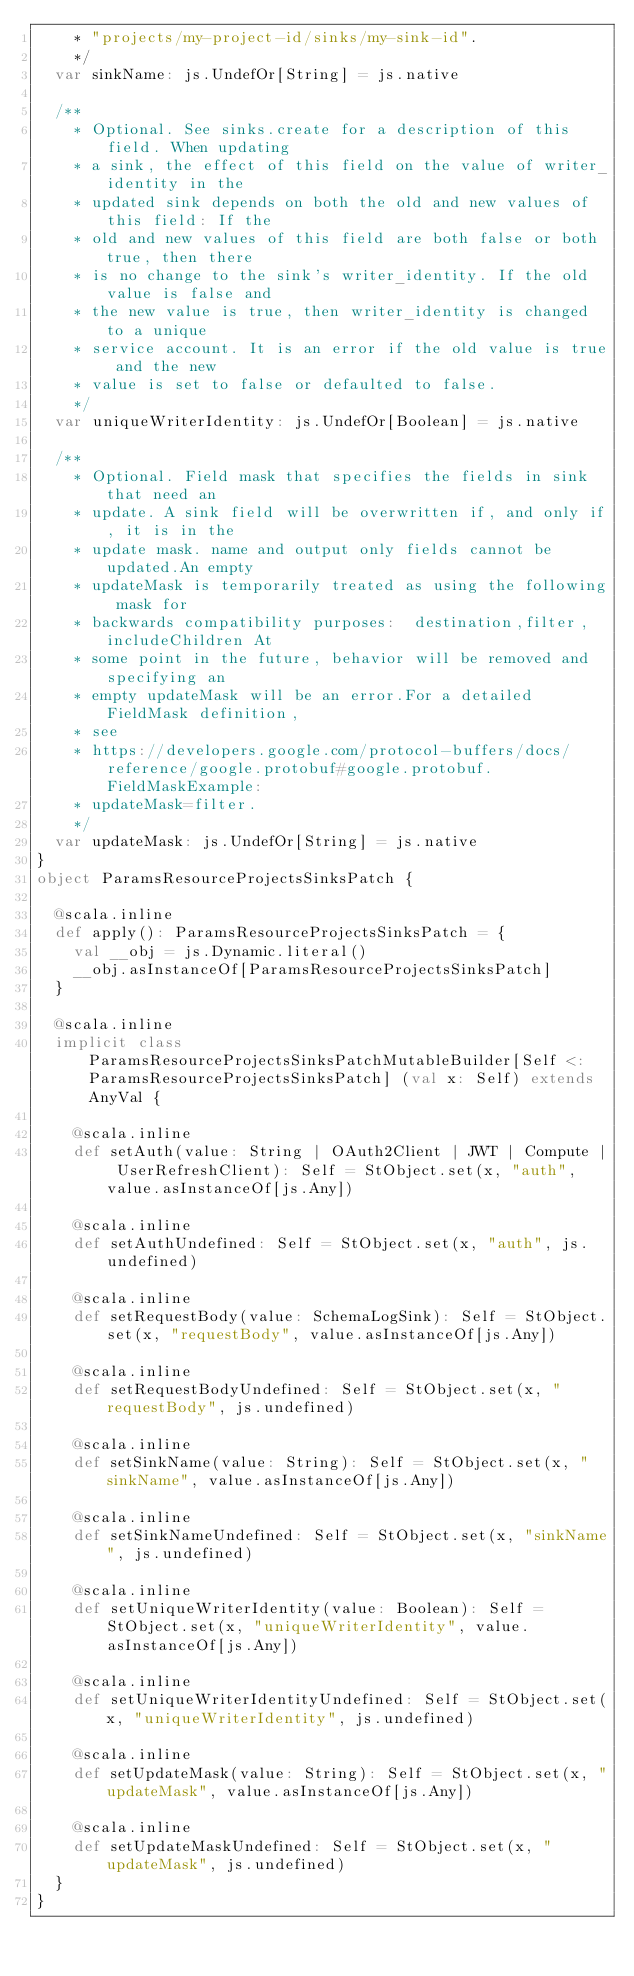<code> <loc_0><loc_0><loc_500><loc_500><_Scala_>    * "projects/my-project-id/sinks/my-sink-id".
    */
  var sinkName: js.UndefOr[String] = js.native
  
  /**
    * Optional. See sinks.create for a description of this field. When updating
    * a sink, the effect of this field on the value of writer_identity in the
    * updated sink depends on both the old and new values of this field: If the
    * old and new values of this field are both false or both true, then there
    * is no change to the sink's writer_identity. If the old value is false and
    * the new value is true, then writer_identity is changed to a unique
    * service account. It is an error if the old value is true and the new
    * value is set to false or defaulted to false.
    */
  var uniqueWriterIdentity: js.UndefOr[Boolean] = js.native
  
  /**
    * Optional. Field mask that specifies the fields in sink that need an
    * update. A sink field will be overwritten if, and only if, it is in the
    * update mask. name and output only fields cannot be updated.An empty
    * updateMask is temporarily treated as using the following mask for
    * backwards compatibility purposes:  destination,filter,includeChildren At
    * some point in the future, behavior will be removed and specifying an
    * empty updateMask will be an error.For a detailed FieldMask definition,
    * see
    * https://developers.google.com/protocol-buffers/docs/reference/google.protobuf#google.protobuf.FieldMaskExample:
    * updateMask=filter.
    */
  var updateMask: js.UndefOr[String] = js.native
}
object ParamsResourceProjectsSinksPatch {
  
  @scala.inline
  def apply(): ParamsResourceProjectsSinksPatch = {
    val __obj = js.Dynamic.literal()
    __obj.asInstanceOf[ParamsResourceProjectsSinksPatch]
  }
  
  @scala.inline
  implicit class ParamsResourceProjectsSinksPatchMutableBuilder[Self <: ParamsResourceProjectsSinksPatch] (val x: Self) extends AnyVal {
    
    @scala.inline
    def setAuth(value: String | OAuth2Client | JWT | Compute | UserRefreshClient): Self = StObject.set(x, "auth", value.asInstanceOf[js.Any])
    
    @scala.inline
    def setAuthUndefined: Self = StObject.set(x, "auth", js.undefined)
    
    @scala.inline
    def setRequestBody(value: SchemaLogSink): Self = StObject.set(x, "requestBody", value.asInstanceOf[js.Any])
    
    @scala.inline
    def setRequestBodyUndefined: Self = StObject.set(x, "requestBody", js.undefined)
    
    @scala.inline
    def setSinkName(value: String): Self = StObject.set(x, "sinkName", value.asInstanceOf[js.Any])
    
    @scala.inline
    def setSinkNameUndefined: Self = StObject.set(x, "sinkName", js.undefined)
    
    @scala.inline
    def setUniqueWriterIdentity(value: Boolean): Self = StObject.set(x, "uniqueWriterIdentity", value.asInstanceOf[js.Any])
    
    @scala.inline
    def setUniqueWriterIdentityUndefined: Self = StObject.set(x, "uniqueWriterIdentity", js.undefined)
    
    @scala.inline
    def setUpdateMask(value: String): Self = StObject.set(x, "updateMask", value.asInstanceOf[js.Any])
    
    @scala.inline
    def setUpdateMaskUndefined: Self = StObject.set(x, "updateMask", js.undefined)
  }
}
</code> 